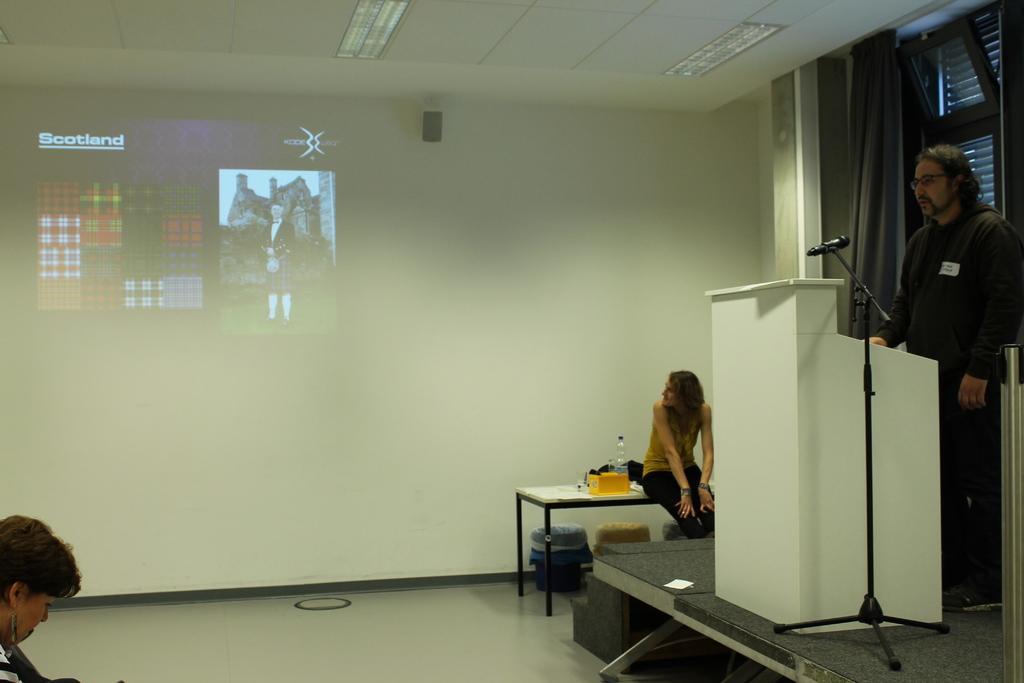Could you give a brief overview of what you see in this image? In this image, I can see the man standing. This is the stage with the stairs. Here is a person sitting on the table. I can see a mike with a mike stand. This is a podium, which is white in color. I can see the display on the wall. These are the ceiling lights, which are attached to the ceiling. I can see a curtain hanging to a hanger. I think this is a window with the doors. I can see few objects on the table. I think these are the dustbins, which are under the table. At the bottom left corner of the image, I can see another person. This is the floor. 